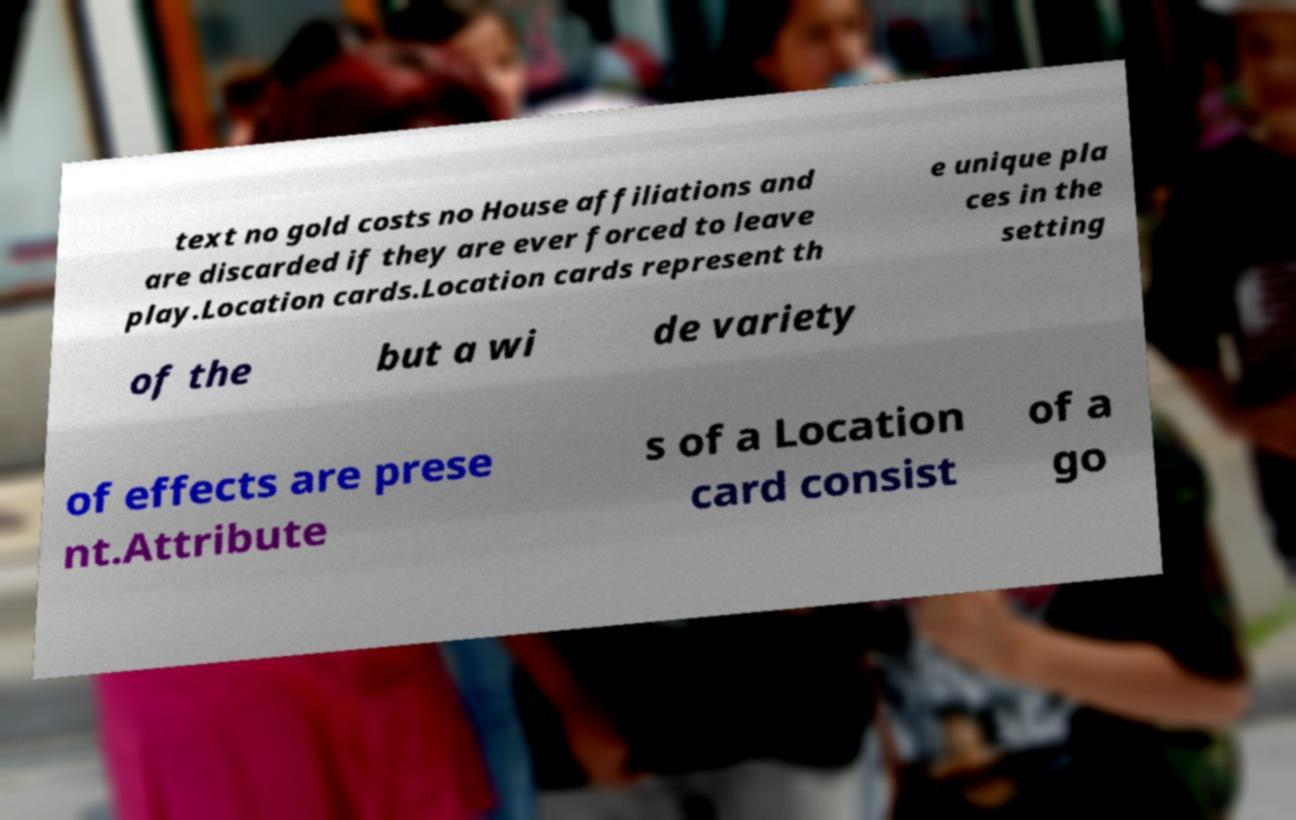Please identify and transcribe the text found in this image. text no gold costs no House affiliations and are discarded if they are ever forced to leave play.Location cards.Location cards represent th e unique pla ces in the setting of the but a wi de variety of effects are prese nt.Attribute s of a Location card consist of a go 